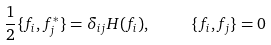Convert formula to latex. <formula><loc_0><loc_0><loc_500><loc_500>\frac { 1 } { 2 } \{ f _ { i } , f _ { j } ^ { * } \} = \delta _ { i j } H ( f _ { i } ) , \quad \ \{ f _ { i } , f _ { j } \} = 0</formula> 